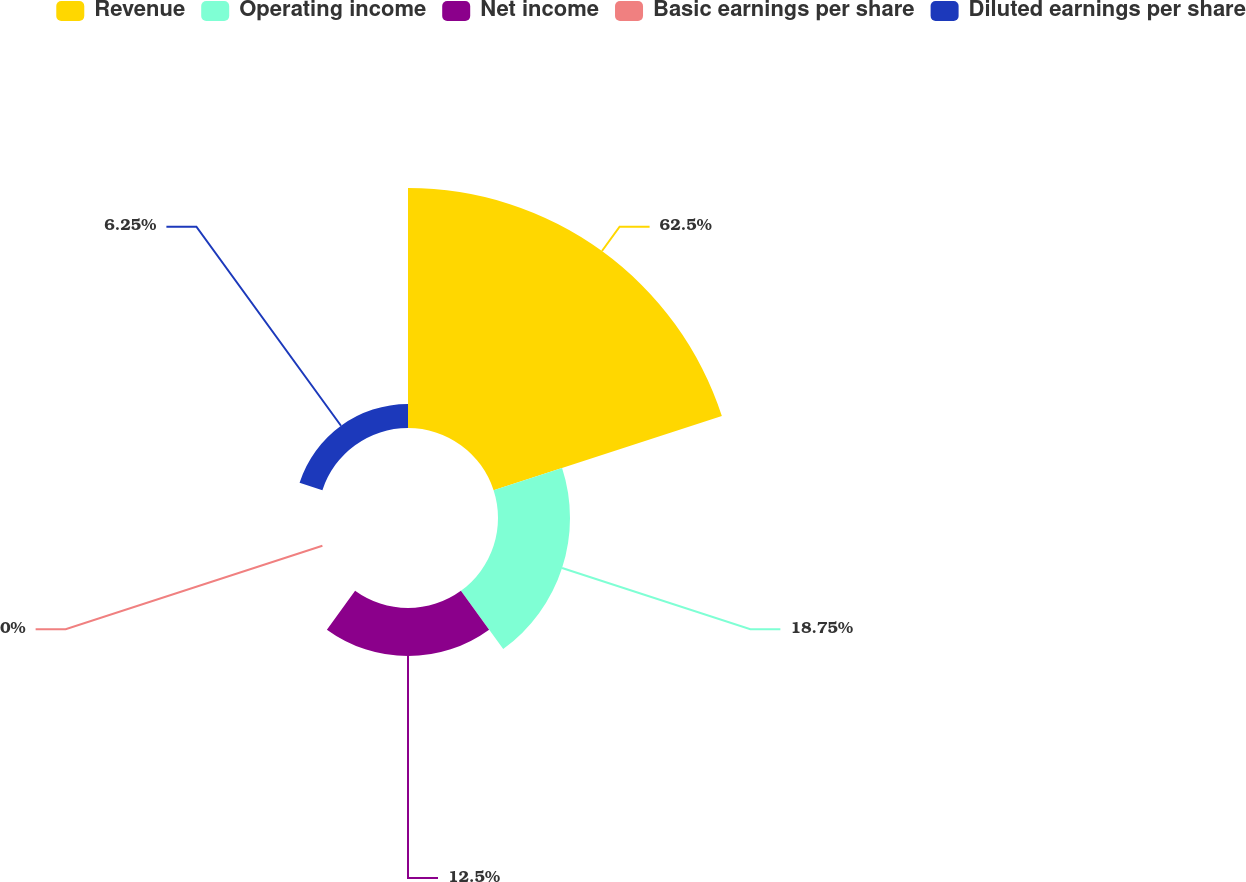Convert chart. <chart><loc_0><loc_0><loc_500><loc_500><pie_chart><fcel>Revenue<fcel>Operating income<fcel>Net income<fcel>Basic earnings per share<fcel>Diluted earnings per share<nl><fcel>62.5%<fcel>18.75%<fcel>12.5%<fcel>0.0%<fcel>6.25%<nl></chart> 